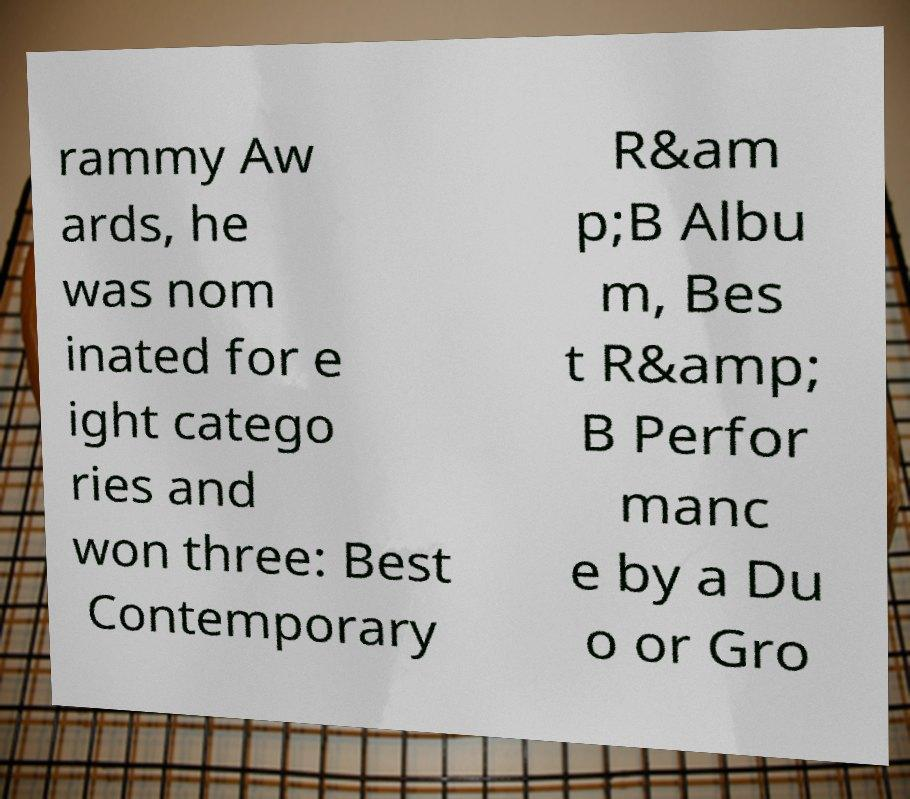For documentation purposes, I need the text within this image transcribed. Could you provide that? rammy Aw ards, he was nom inated for e ight catego ries and won three: Best Contemporary R&am p;B Albu m, Bes t R&amp; B Perfor manc e by a Du o or Gro 